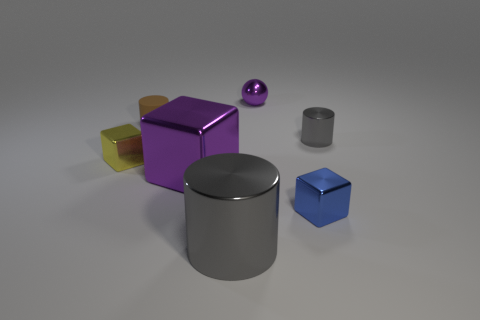How many gray cylinders must be subtracted to get 1 gray cylinders? 1 Add 3 yellow blocks. How many objects exist? 10 Subtract all balls. How many objects are left? 6 Add 3 cubes. How many cubes are left? 6 Add 7 small yellow shiny cubes. How many small yellow shiny cubes exist? 8 Subtract 0 cyan cylinders. How many objects are left? 7 Subtract all brown cylinders. Subtract all balls. How many objects are left? 5 